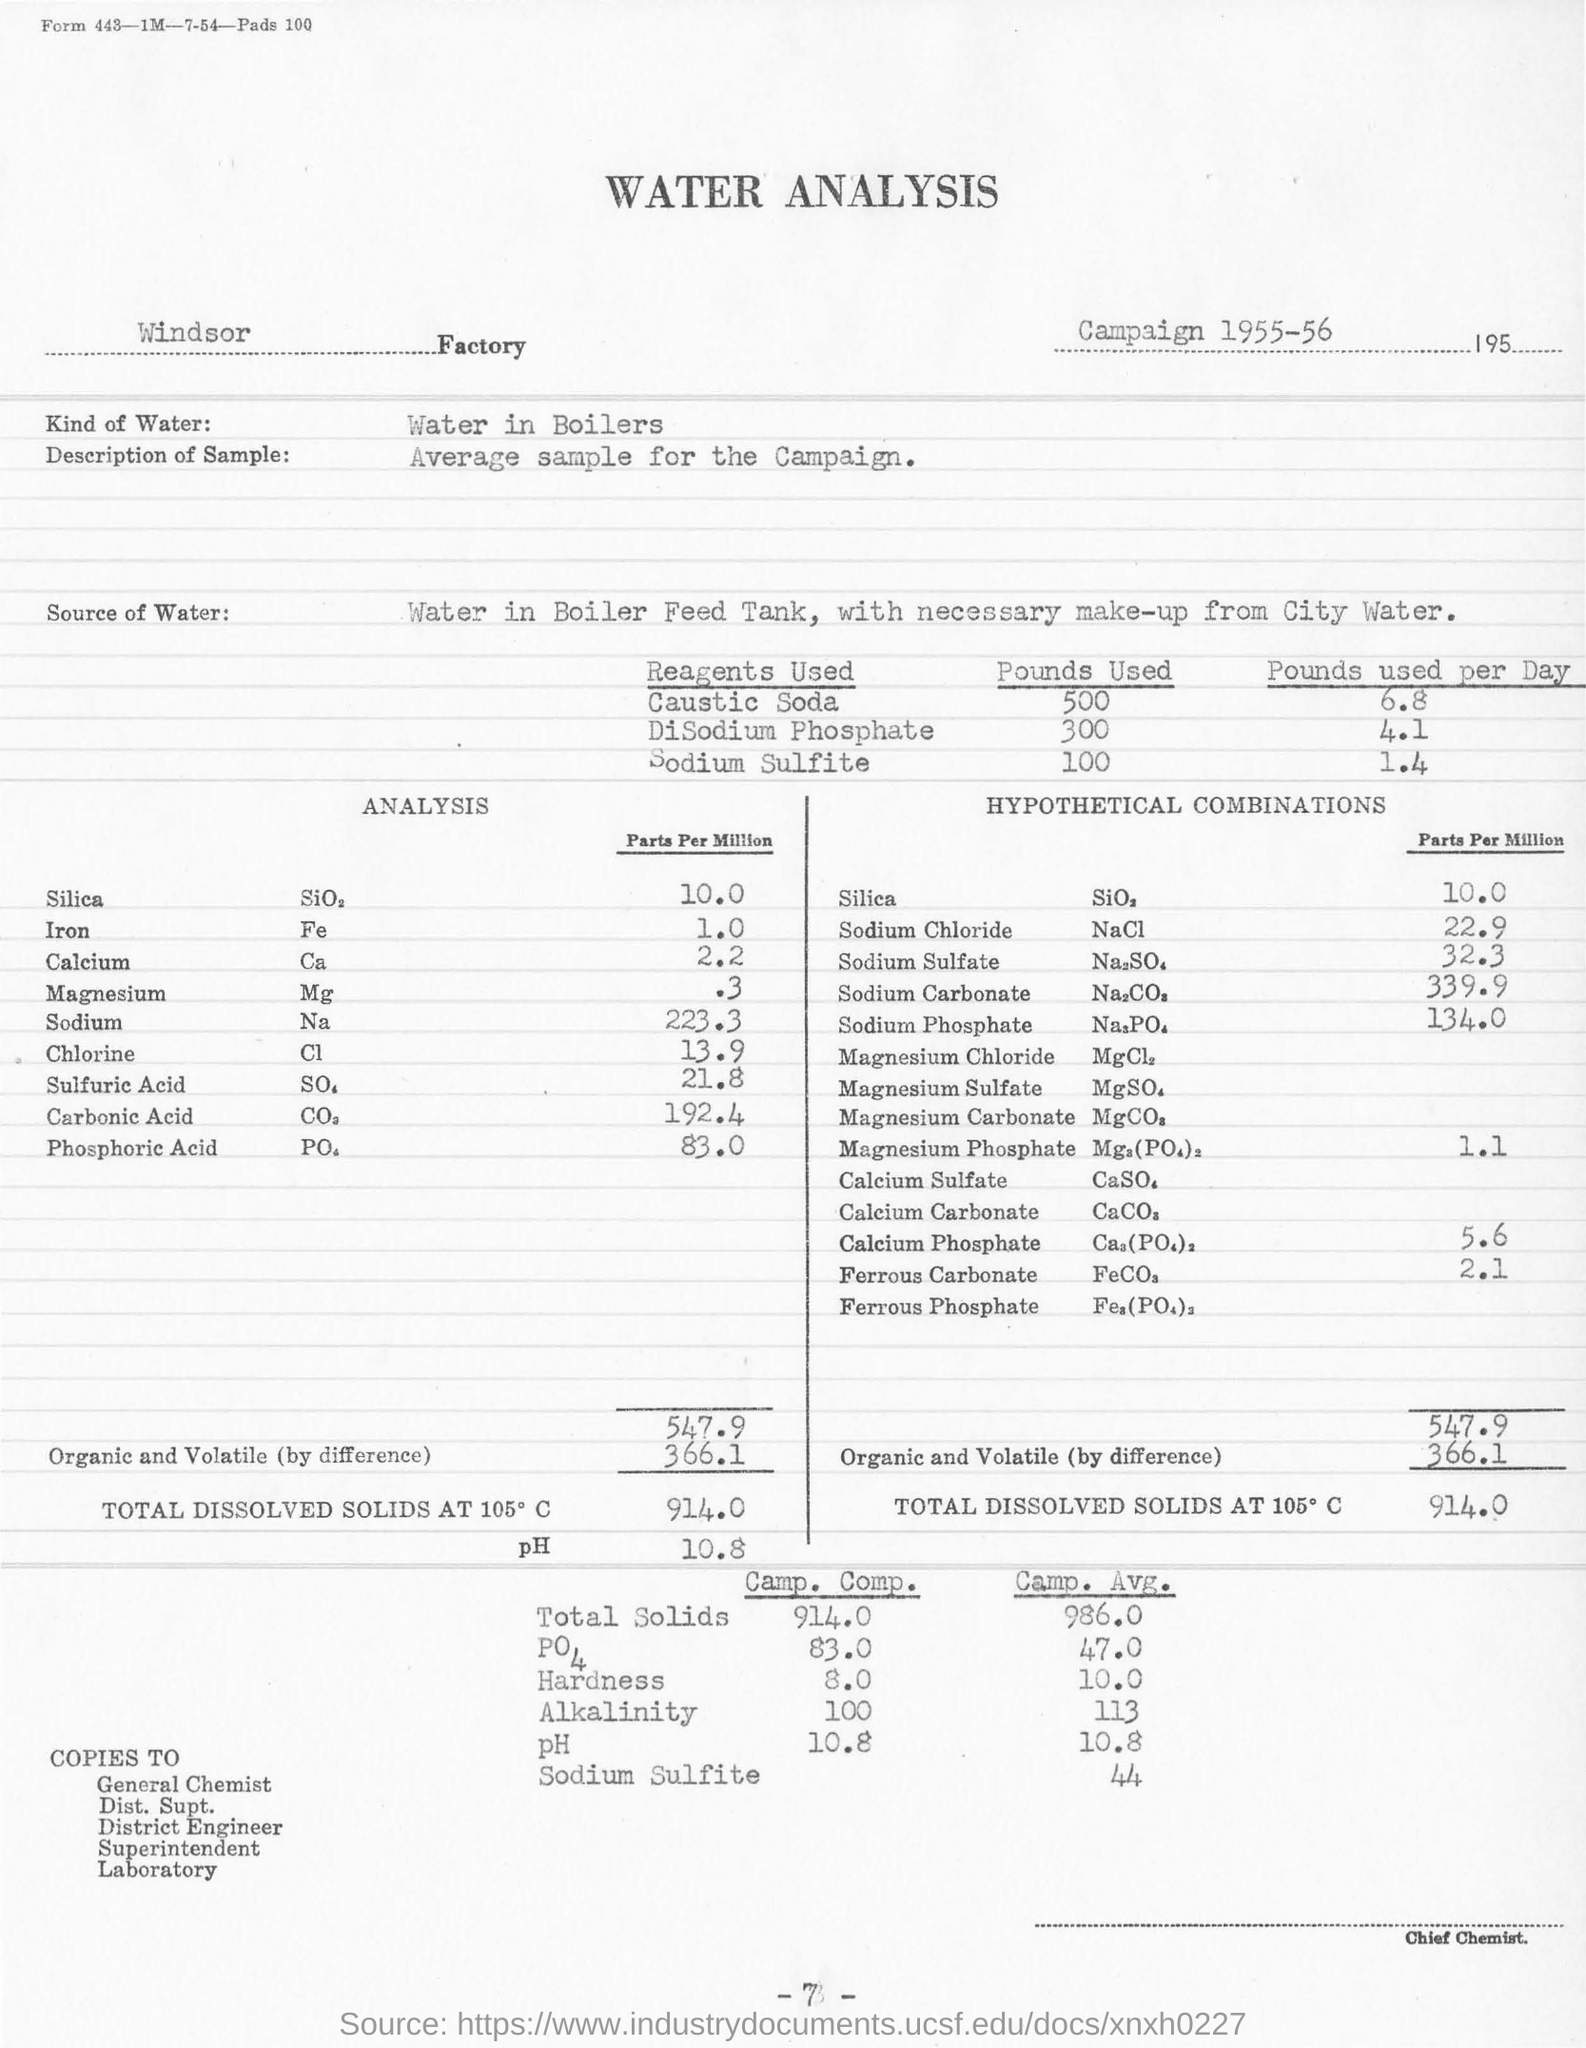What is the year of Campaign ?
Provide a succinct answer. 1955-56. Which kind of Water ?
Keep it short and to the point. Water in Boilers. What is the Description of Sample ?
Your response must be concise. Average sample for the Campaign. How many Pounds of Caustic Soda used per Day?
Make the answer very short. 6.8. How many Pounds of DiSodium Phosphate used?
Provide a short and direct response. 300. 